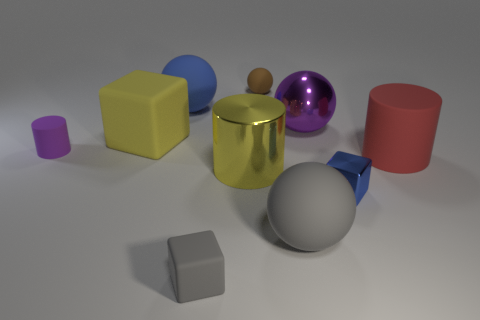Subtract all balls. How many objects are left? 6 Add 1 large spheres. How many large spheres exist? 4 Subtract 0 cyan cubes. How many objects are left? 10 Subtract all small matte balls. Subtract all large rubber cubes. How many objects are left? 8 Add 8 purple things. How many purple things are left? 10 